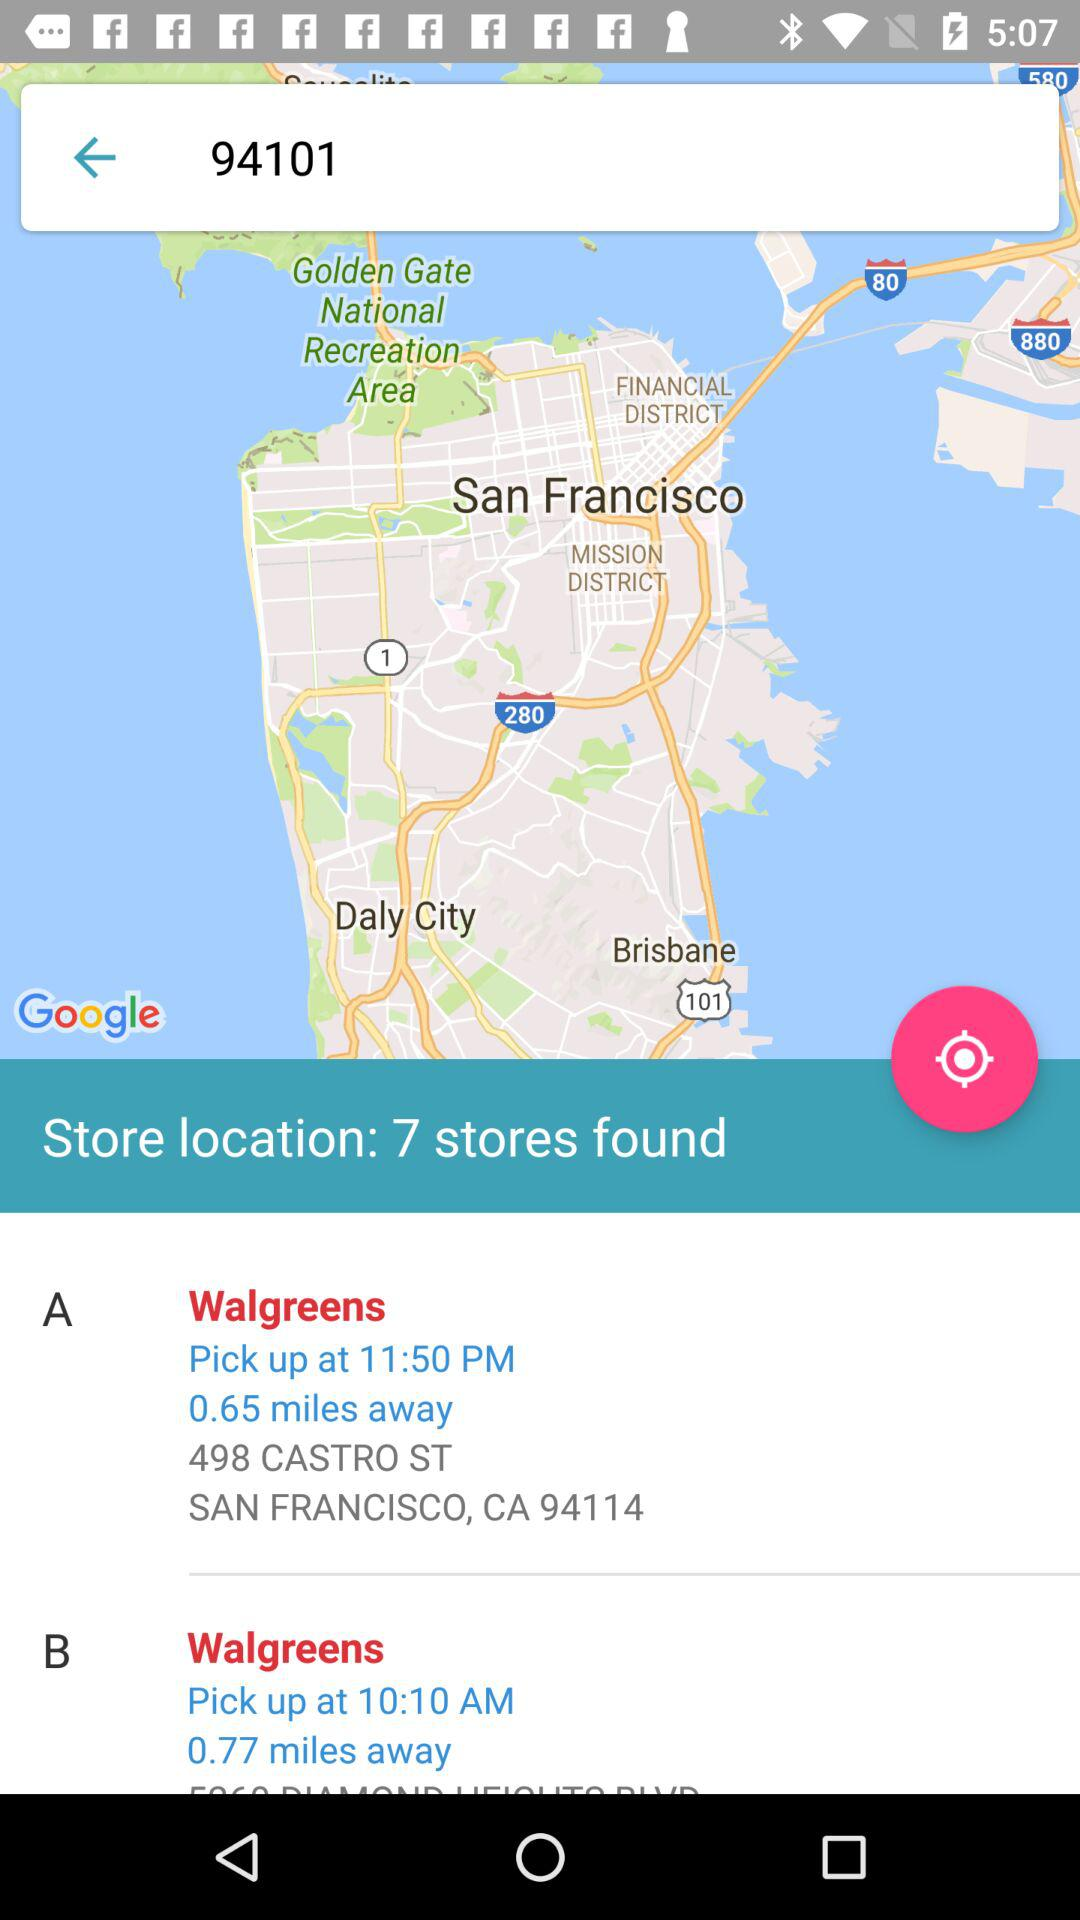How much is the distance to Walgreens-B? The distance to Walgreens-B is 0.77 miles. 